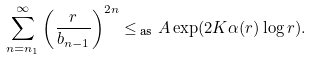<formula> <loc_0><loc_0><loc_500><loc_500>\sum _ { n = n _ { 1 } } ^ { \infty } \left ( \frac { r } { b _ { n - 1 } } \right ) ^ { 2 n } \leq _ { \text { as} } A \exp ( 2 K \alpha ( r ) \log r ) .</formula> 